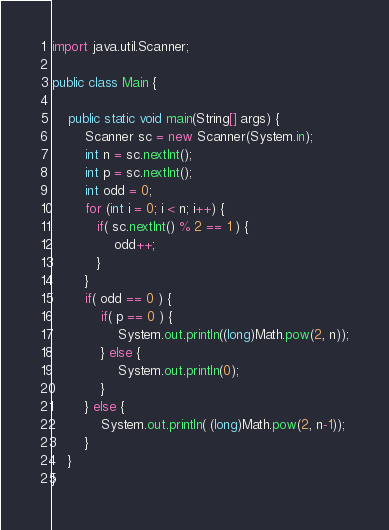Convert code to text. <code><loc_0><loc_0><loc_500><loc_500><_Java_>import java.util.Scanner;

public class Main {

    public static void main(String[] args) {
        Scanner sc = new Scanner(System.in);
        int n = sc.nextInt();
        int p = sc.nextInt();
        int odd = 0;
        for (int i = 0; i < n; i++) {
           if( sc.nextInt() % 2 == 1 ) {
               odd++;
           }
        }
        if( odd == 0 ) {
            if( p == 0 ) {
                System.out.println((long)Math.pow(2, n));
            } else {
                System.out.println(0);
            }
        } else {
            System.out.println( (long)Math.pow(2, n-1));
        }
    }
}
</code> 